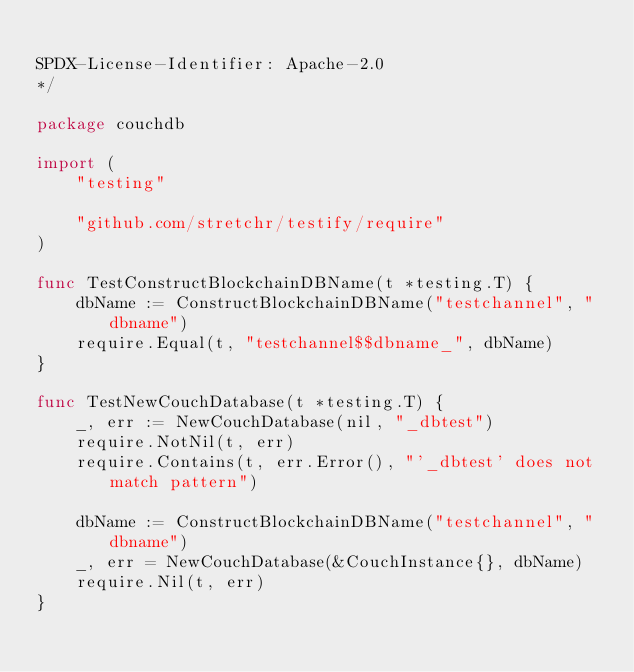<code> <loc_0><loc_0><loc_500><loc_500><_Go_>
SPDX-License-Identifier: Apache-2.0
*/

package couchdb

import (
	"testing"

	"github.com/stretchr/testify/require"
)

func TestConstructBlockchainDBName(t *testing.T) {
	dbName := ConstructBlockchainDBName("testchannel", "dbname")
	require.Equal(t, "testchannel$$dbname_", dbName)
}

func TestNewCouchDatabase(t *testing.T) {
	_, err := NewCouchDatabase(nil, "_dbtest")
	require.NotNil(t, err)
	require.Contains(t, err.Error(), "'_dbtest' does not match pattern")

	dbName := ConstructBlockchainDBName("testchannel", "dbname")
	_, err = NewCouchDatabase(&CouchInstance{}, dbName)
	require.Nil(t, err)
}
</code> 